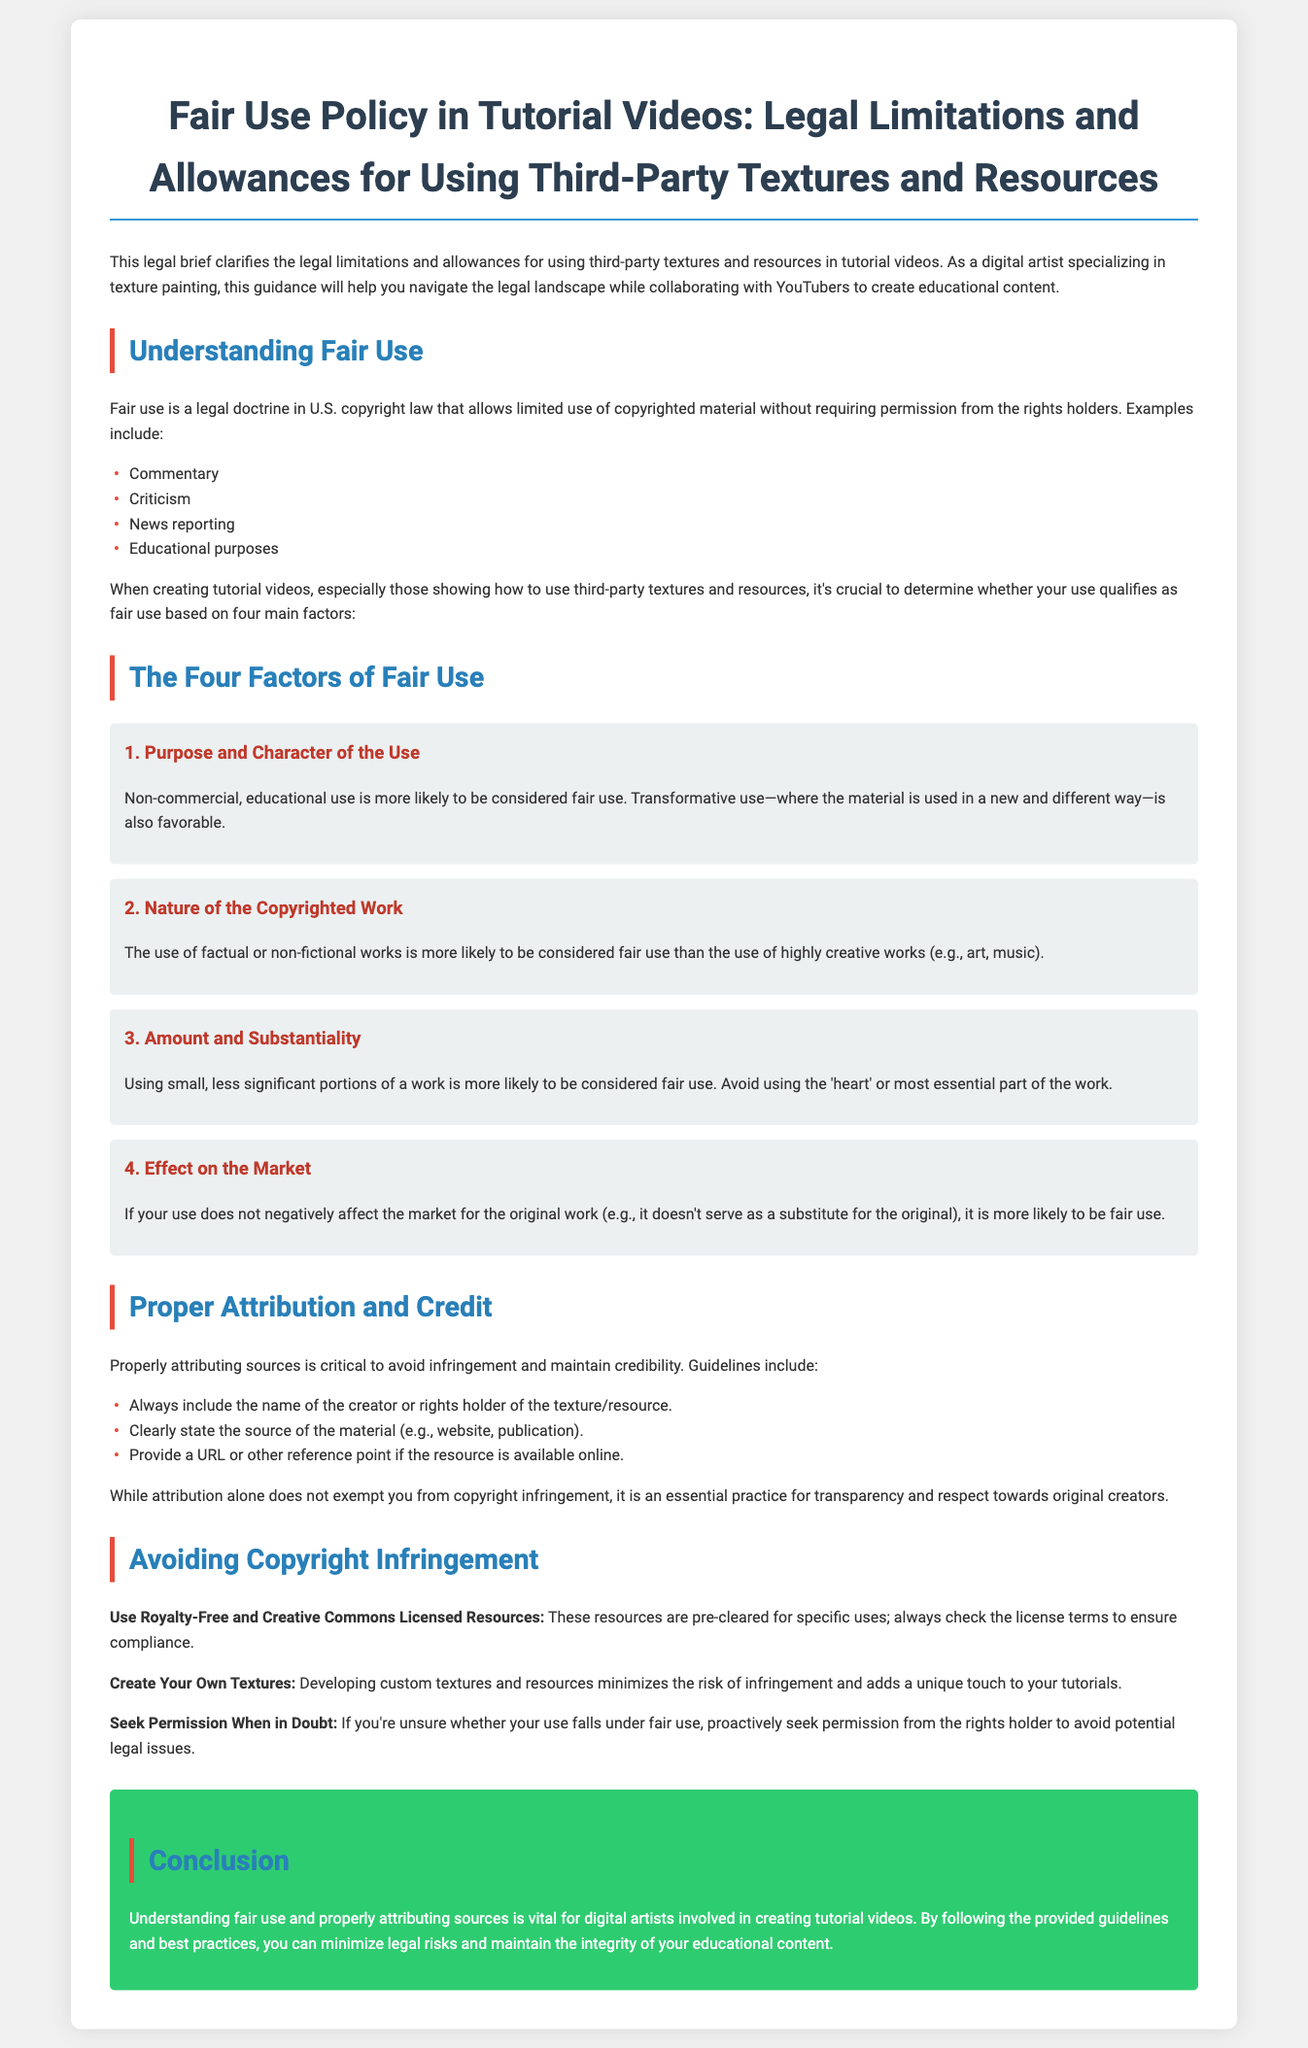What is the title of the document? The title is the main heading of the document and can be found at the top of the text.
Answer: Fair Use Policy in Tutorial Videos: Legal Limitations and Allowances for Using Third-Party Textures and Resources What are the four factors of fair use? The factors are listed under their own section and highlight important criteria for determining fair use.
Answer: Purpose and Character of the Use, Nature of the Copyrighted Work, Amount and Substantiality, Effect on the Market How should sources be attributed? The document outlines guidelines for proper attribution in the section dedicated to this topic.
Answer: Include the creator's name, source, and a URL if applicable What should you do if you're unsure about fair use? The document provides advice in the section about avoiding copyright infringement, indicating the recommended action.
Answer: Seek Permission When in Doubt What type of resources should artists use to avoid infringement? This information is covered in the section that discusses avoiding copyright infringement, specifying resource types to consider.
Answer: Royalty-Free and Creative Commons Licensed Resources Why is transformative use favorable? This reasoning is specified under the purpose and character of the use in the fair use factors.
Answer: Non-commercial, educational use What does the conclusion emphasize for digital artists? The conclusion summarizes the key takeaways for artists creating tutorial content in the document.
Answer: Understanding fair use and properly attributing sources 